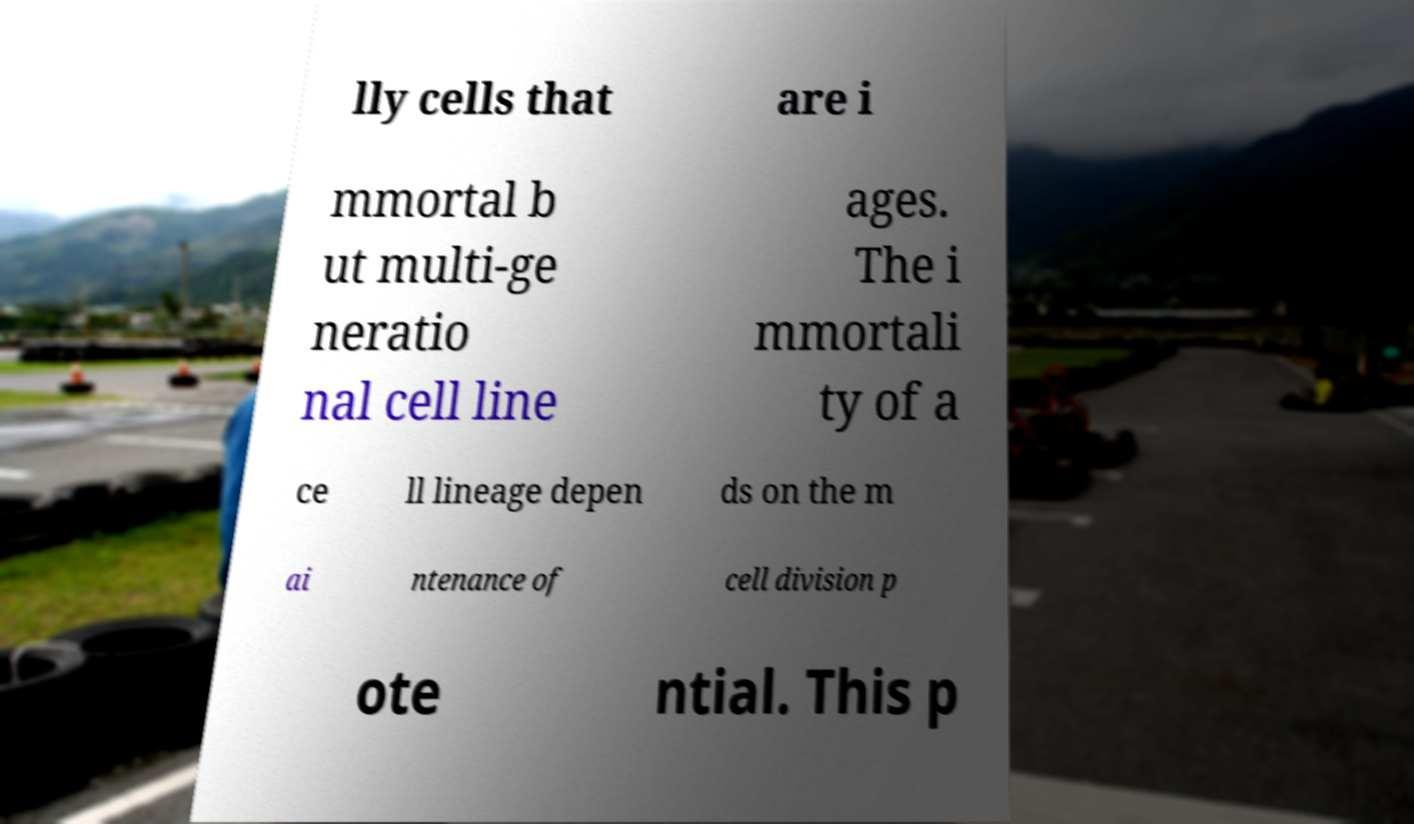I need the written content from this picture converted into text. Can you do that? lly cells that are i mmortal b ut multi-ge neratio nal cell line ages. The i mmortali ty of a ce ll lineage depen ds on the m ai ntenance of cell division p ote ntial. This p 